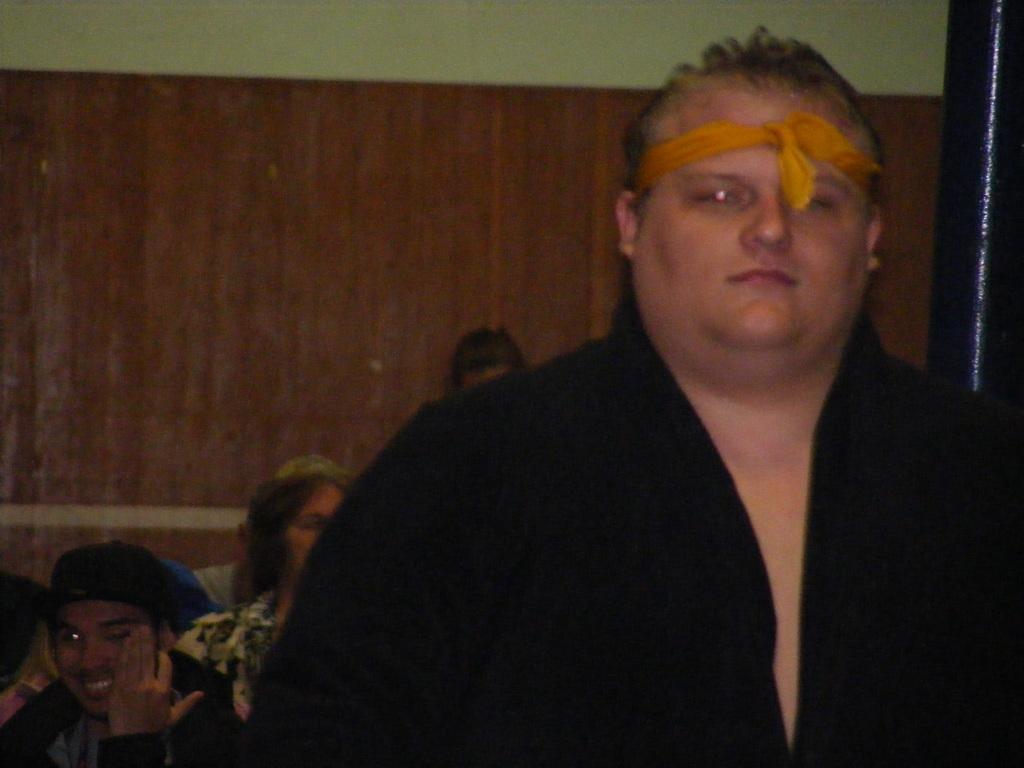In one or two sentences, can you explain what this image depicts? In this picture I can see a man with a cloth tied to his forehead. I can see few people, and in the background there is a wall. 